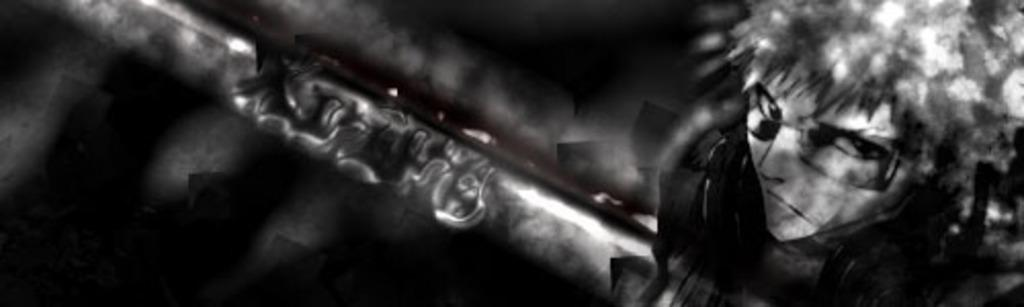What is present in the image? There is a person in the image. What is the person holding in their hand? The person is holding an object in their hand. Can you describe the background of the image? The background of the image is dark. What type of heart can be seen growing in the bushes in the image? There is no heart or bushes present in the image; it features a person holding an object against a dark background. 